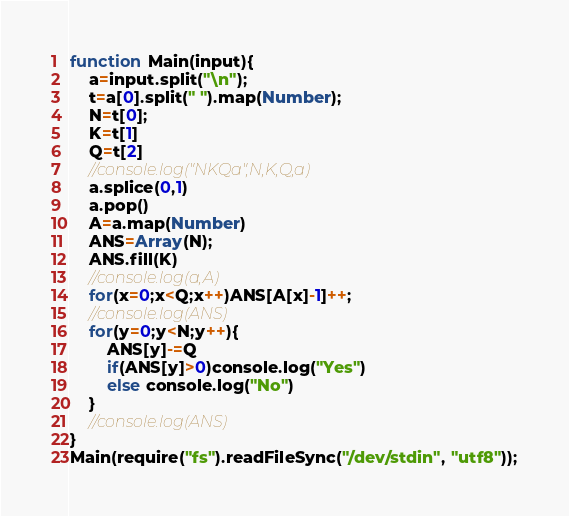<code> <loc_0><loc_0><loc_500><loc_500><_JavaScript_>function Main(input){
    a=input.split("\n");
    t=a[0].split(" ").map(Number);
    N=t[0];
    K=t[1]
    Q=t[2]
    //console.log("NKQa",N,K,Q,a)
    a.splice(0,1)
    a.pop()
    A=a.map(Number)
    ANS=Array(N);
    ANS.fill(K)
    //console.log(a,A)
    for(x=0;x<Q;x++)ANS[A[x]-1]++;
    //console.log(ANS)
    for(y=0;y<N;y++){
        ANS[y]-=Q
        if(ANS[y]>0)console.log("Yes")
        else console.log("No")
    }
    //console.log(ANS)
}
Main(require("fs").readFileSync("/dev/stdin", "utf8"));</code> 